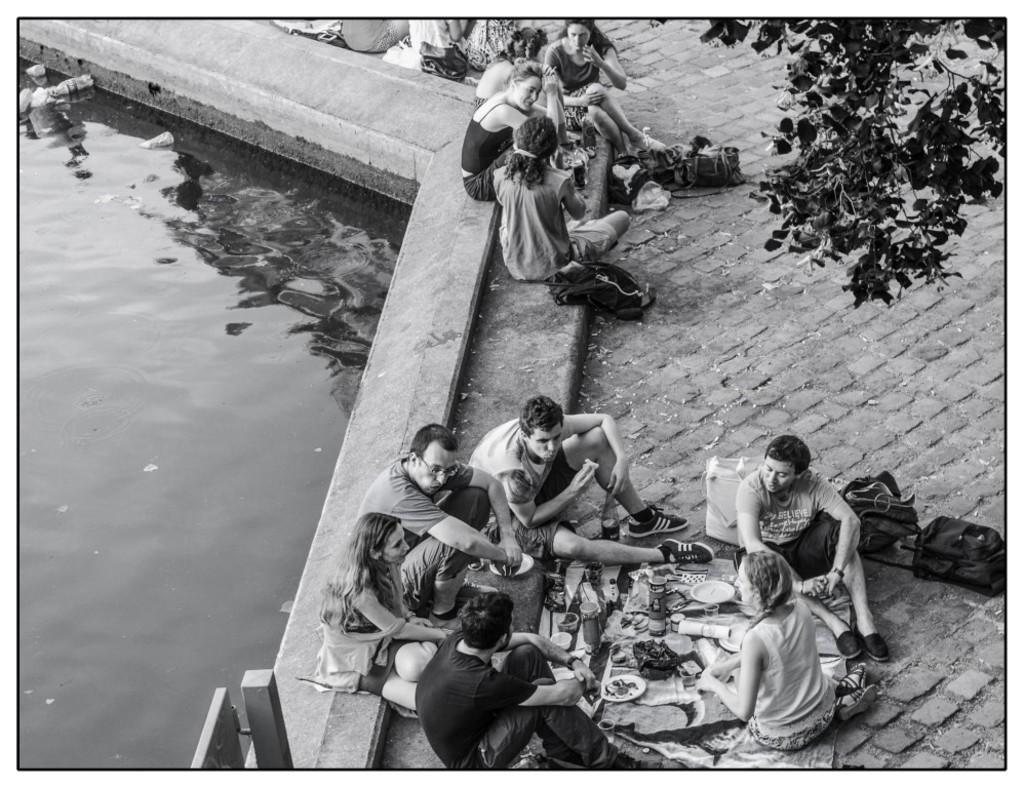Can you describe this image briefly? In this picture we can see water, tree, pole, bags, bottles, plates and some objects and a group of people sitting on the ground. 